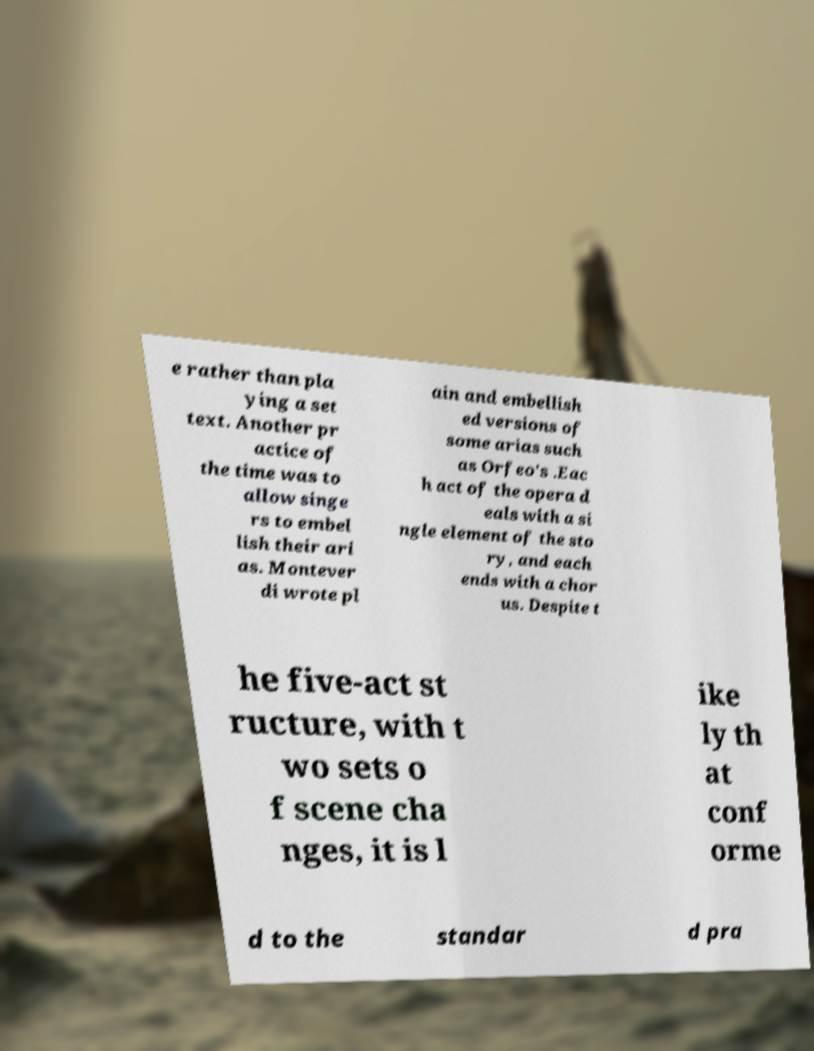There's text embedded in this image that I need extracted. Can you transcribe it verbatim? e rather than pla ying a set text. Another pr actice of the time was to allow singe rs to embel lish their ari as. Montever di wrote pl ain and embellish ed versions of some arias such as Orfeo's .Eac h act of the opera d eals with a si ngle element of the sto ry, and each ends with a chor us. Despite t he five-act st ructure, with t wo sets o f scene cha nges, it is l ike ly th at conf orme d to the standar d pra 